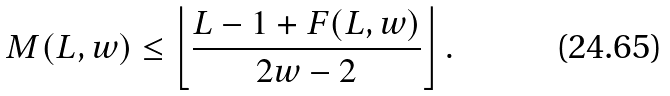Convert formula to latex. <formula><loc_0><loc_0><loc_500><loc_500>M ( L , w ) \leq \left \lfloor \frac { L - 1 + F ( L , w ) } { 2 w - 2 } \right \rfloor .</formula> 